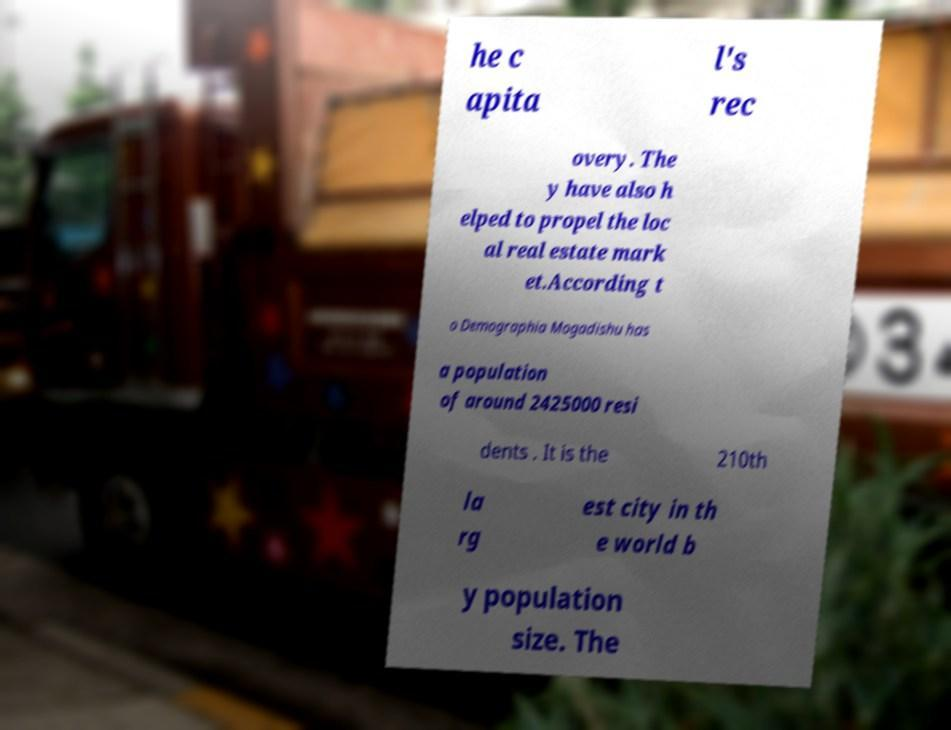For documentation purposes, I need the text within this image transcribed. Could you provide that? he c apita l's rec overy. The y have also h elped to propel the loc al real estate mark et.According t o Demographia Mogadishu has a population of around 2425000 resi dents . It is the 210th la rg est city in th e world b y population size. The 